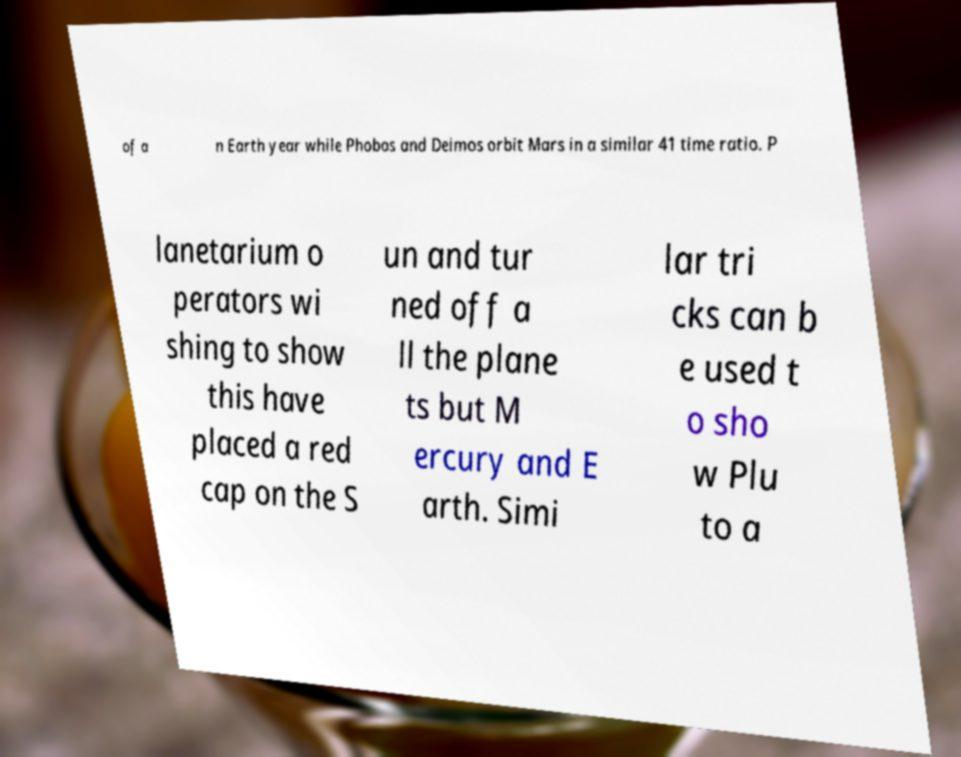Can you accurately transcribe the text from the provided image for me? of a n Earth year while Phobos and Deimos orbit Mars in a similar 41 time ratio. P lanetarium o perators wi shing to show this have placed a red cap on the S un and tur ned off a ll the plane ts but M ercury and E arth. Simi lar tri cks can b e used t o sho w Plu to a 